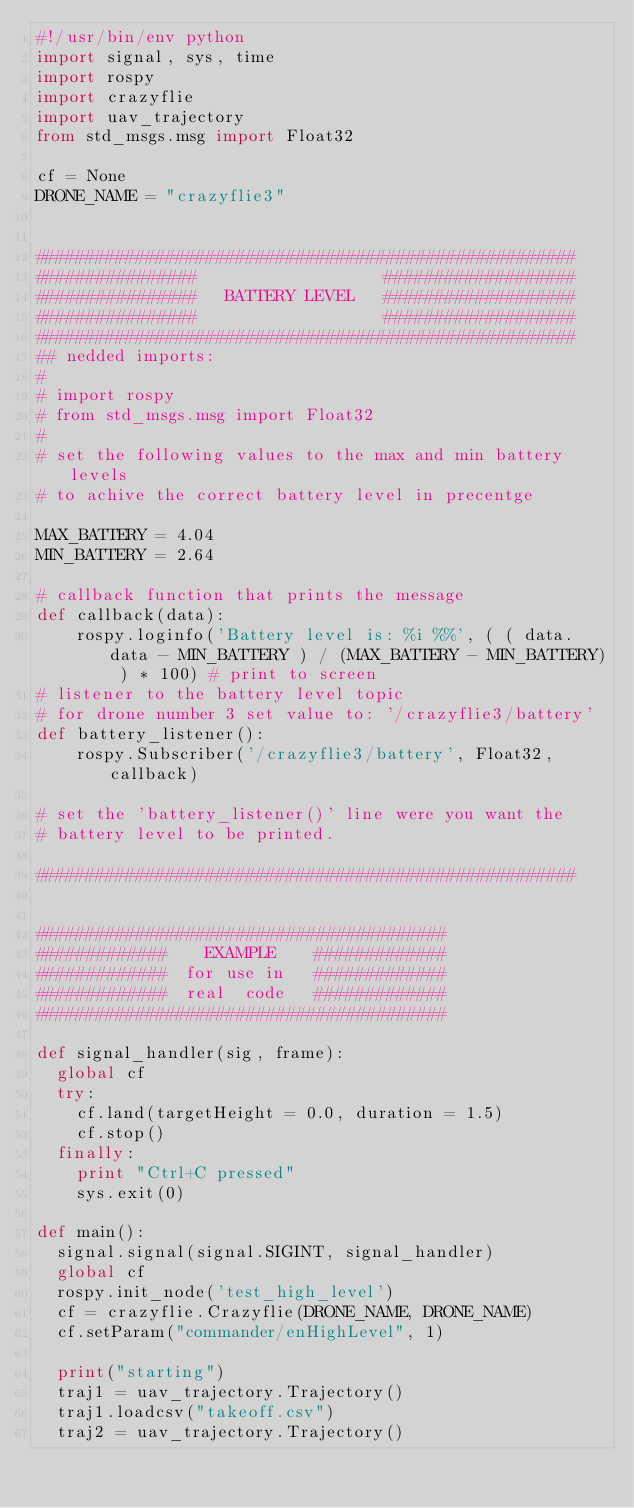<code> <loc_0><loc_0><loc_500><loc_500><_Python_>#!/usr/bin/env python
import signal, sys, time
import rospy
import crazyflie
import uav_trajectory
from std_msgs.msg import Float32

cf = None
DRONE_NAME = "crazyflie3"


######################################################
################                   ###################
################   BATTERY LEVEL   ###################
################                   ###################
######################################################
## nedded imports: 
#
# import rospy
# from std_msgs.msg import Float32
#
# set the following values to the max and min battery levels
# to achive the correct battery level in precentge

MAX_BATTERY = 4.04
MIN_BATTERY = 2.64

# callback function that prints the message
def callback(data):
    rospy.loginfo('Battery level is: %i %%', ( ( data.data - MIN_BATTERY ) / (MAX_BATTERY - MIN_BATTERY) ) * 100) # print to screen
# listener to the battery level topic
# for drone number 3 set value to: '/crazyflie3/battery'
def battery_listener():
    rospy.Subscriber('/crazyflie3/battery', Float32, callback)

# set the 'battery_listener()' line were you want the
# battery level to be printed.  

######################################################


#########################################
#############    EXAMPLE    ############# 
#############  for use in   #############
#############  real  code   #############
#########################################

def signal_handler(sig, frame):
	global cf
	try:
		cf.land(targetHeight = 0.0, duration = 1.5)
		cf.stop()
	finally:
		print "Ctrl+C pressed"
		sys.exit(0)

def main():
	signal.signal(signal.SIGINT, signal_handler)
	global cf
	rospy.init_node('test_high_level')
	cf = crazyflie.Crazyflie(DRONE_NAME, DRONE_NAME)
	cf.setParam("commander/enHighLevel", 1)

	print("starting")
	traj1 = uav_trajectory.Trajectory()
	traj1.loadcsv("takeoff.csv")
	traj2 = uav_trajectory.Trajectory()</code> 